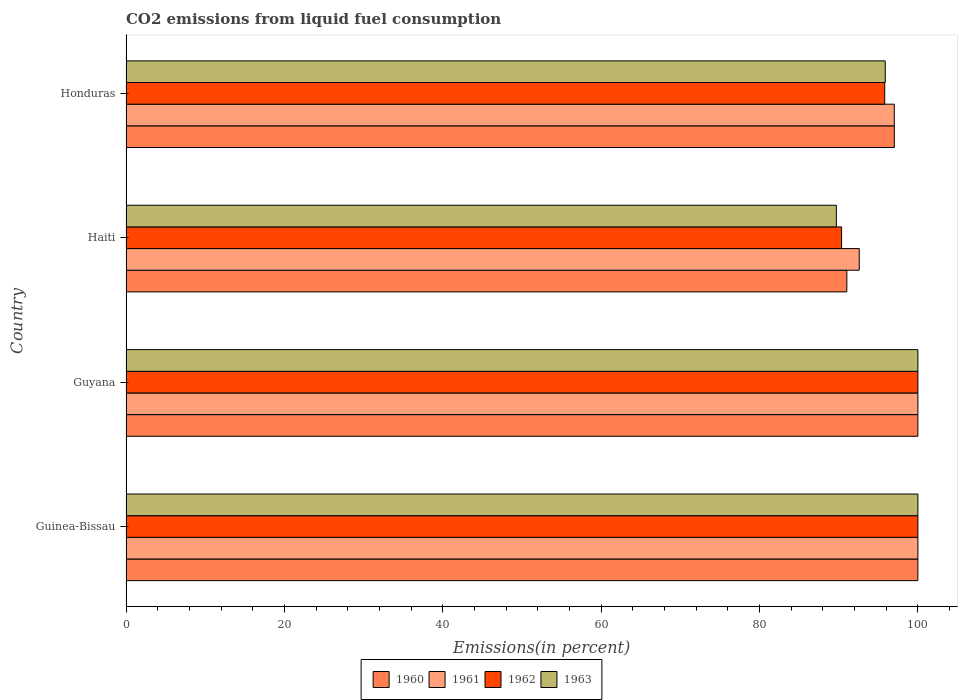How many groups of bars are there?
Provide a succinct answer. 4. Are the number of bars per tick equal to the number of legend labels?
Offer a very short reply. Yes. Are the number of bars on each tick of the Y-axis equal?
Provide a short and direct response. Yes. What is the label of the 3rd group of bars from the top?
Offer a terse response. Guyana. In how many cases, is the number of bars for a given country not equal to the number of legend labels?
Your answer should be compact. 0. Across all countries, what is the maximum total CO2 emitted in 1963?
Your answer should be very brief. 100. Across all countries, what is the minimum total CO2 emitted in 1960?
Your response must be concise. 91.03. In which country was the total CO2 emitted in 1960 maximum?
Provide a short and direct response. Guinea-Bissau. In which country was the total CO2 emitted in 1960 minimum?
Ensure brevity in your answer.  Haiti. What is the total total CO2 emitted in 1963 in the graph?
Make the answer very short. 385.58. What is the difference between the total CO2 emitted in 1963 in Haiti and the total CO2 emitted in 1961 in Honduras?
Offer a very short reply. -7.31. What is the average total CO2 emitted in 1963 per country?
Offer a very short reply. 96.4. In how many countries, is the total CO2 emitted in 1960 greater than 24 %?
Offer a very short reply. 4. What is the ratio of the total CO2 emitted in 1960 in Haiti to that in Honduras?
Provide a short and direct response. 0.94. Is the total CO2 emitted in 1963 in Guinea-Bissau less than that in Haiti?
Give a very brief answer. No. Is the difference between the total CO2 emitted in 1963 in Guinea-Bissau and Guyana greater than the difference between the total CO2 emitted in 1960 in Guinea-Bissau and Guyana?
Provide a succinct answer. No. What is the difference between the highest and the second highest total CO2 emitted in 1962?
Ensure brevity in your answer.  0. What is the difference between the highest and the lowest total CO2 emitted in 1963?
Provide a succinct answer. 10.29. In how many countries, is the total CO2 emitted in 1961 greater than the average total CO2 emitted in 1961 taken over all countries?
Make the answer very short. 2. What does the 4th bar from the top in Haiti represents?
Give a very brief answer. 1960. What does the 4th bar from the bottom in Guyana represents?
Your answer should be very brief. 1963. How many bars are there?
Your response must be concise. 16. Are all the bars in the graph horizontal?
Keep it short and to the point. Yes. How many countries are there in the graph?
Provide a short and direct response. 4. What is the difference between two consecutive major ticks on the X-axis?
Keep it short and to the point. 20. Does the graph contain any zero values?
Keep it short and to the point. No. How many legend labels are there?
Keep it short and to the point. 4. How are the legend labels stacked?
Offer a terse response. Horizontal. What is the title of the graph?
Your response must be concise. CO2 emissions from liquid fuel consumption. What is the label or title of the X-axis?
Offer a very short reply. Emissions(in percent). What is the label or title of the Y-axis?
Your answer should be compact. Country. What is the Emissions(in percent) of 1960 in Guinea-Bissau?
Give a very brief answer. 100. What is the Emissions(in percent) of 1961 in Guinea-Bissau?
Your response must be concise. 100. What is the Emissions(in percent) of 1963 in Guinea-Bissau?
Keep it short and to the point. 100. What is the Emissions(in percent) in 1960 in Guyana?
Offer a very short reply. 100. What is the Emissions(in percent) of 1960 in Haiti?
Ensure brevity in your answer.  91.03. What is the Emissions(in percent) in 1961 in Haiti?
Provide a short and direct response. 92.59. What is the Emissions(in percent) of 1962 in Haiti?
Make the answer very short. 90.36. What is the Emissions(in percent) in 1963 in Haiti?
Offer a terse response. 89.71. What is the Emissions(in percent) of 1960 in Honduras?
Provide a succinct answer. 97.02. What is the Emissions(in percent) in 1961 in Honduras?
Your answer should be very brief. 97.01. What is the Emissions(in percent) in 1962 in Honduras?
Make the answer very short. 95.81. What is the Emissions(in percent) of 1963 in Honduras?
Make the answer very short. 95.88. Across all countries, what is the maximum Emissions(in percent) of 1960?
Give a very brief answer. 100. Across all countries, what is the maximum Emissions(in percent) in 1962?
Keep it short and to the point. 100. Across all countries, what is the maximum Emissions(in percent) in 1963?
Provide a succinct answer. 100. Across all countries, what is the minimum Emissions(in percent) in 1960?
Make the answer very short. 91.03. Across all countries, what is the minimum Emissions(in percent) of 1961?
Provide a succinct answer. 92.59. Across all countries, what is the minimum Emissions(in percent) of 1962?
Your answer should be compact. 90.36. Across all countries, what is the minimum Emissions(in percent) of 1963?
Your answer should be compact. 89.71. What is the total Emissions(in percent) of 1960 in the graph?
Your answer should be very brief. 388.05. What is the total Emissions(in percent) of 1961 in the graph?
Your answer should be very brief. 389.61. What is the total Emissions(in percent) of 1962 in the graph?
Give a very brief answer. 386.17. What is the total Emissions(in percent) of 1963 in the graph?
Offer a terse response. 385.58. What is the difference between the Emissions(in percent) in 1962 in Guinea-Bissau and that in Guyana?
Provide a short and direct response. 0. What is the difference between the Emissions(in percent) of 1960 in Guinea-Bissau and that in Haiti?
Make the answer very short. 8.97. What is the difference between the Emissions(in percent) of 1961 in Guinea-Bissau and that in Haiti?
Offer a very short reply. 7.41. What is the difference between the Emissions(in percent) of 1962 in Guinea-Bissau and that in Haiti?
Make the answer very short. 9.64. What is the difference between the Emissions(in percent) of 1963 in Guinea-Bissau and that in Haiti?
Offer a terse response. 10.29. What is the difference between the Emissions(in percent) of 1960 in Guinea-Bissau and that in Honduras?
Keep it short and to the point. 2.98. What is the difference between the Emissions(in percent) of 1961 in Guinea-Bissau and that in Honduras?
Offer a terse response. 2.99. What is the difference between the Emissions(in percent) in 1962 in Guinea-Bissau and that in Honduras?
Keep it short and to the point. 4.19. What is the difference between the Emissions(in percent) in 1963 in Guinea-Bissau and that in Honduras?
Offer a terse response. 4.12. What is the difference between the Emissions(in percent) in 1960 in Guyana and that in Haiti?
Keep it short and to the point. 8.97. What is the difference between the Emissions(in percent) of 1961 in Guyana and that in Haiti?
Offer a very short reply. 7.41. What is the difference between the Emissions(in percent) of 1962 in Guyana and that in Haiti?
Offer a very short reply. 9.64. What is the difference between the Emissions(in percent) in 1963 in Guyana and that in Haiti?
Your answer should be very brief. 10.29. What is the difference between the Emissions(in percent) in 1960 in Guyana and that in Honduras?
Your response must be concise. 2.98. What is the difference between the Emissions(in percent) of 1961 in Guyana and that in Honduras?
Ensure brevity in your answer.  2.99. What is the difference between the Emissions(in percent) of 1962 in Guyana and that in Honduras?
Keep it short and to the point. 4.19. What is the difference between the Emissions(in percent) of 1963 in Guyana and that in Honduras?
Make the answer very short. 4.12. What is the difference between the Emissions(in percent) in 1960 in Haiti and that in Honduras?
Provide a succinct answer. -6. What is the difference between the Emissions(in percent) of 1961 in Haiti and that in Honduras?
Your answer should be very brief. -4.42. What is the difference between the Emissions(in percent) of 1962 in Haiti and that in Honduras?
Your answer should be very brief. -5.45. What is the difference between the Emissions(in percent) of 1963 in Haiti and that in Honduras?
Offer a very short reply. -6.17. What is the difference between the Emissions(in percent) of 1960 in Guinea-Bissau and the Emissions(in percent) of 1963 in Guyana?
Your response must be concise. 0. What is the difference between the Emissions(in percent) of 1962 in Guinea-Bissau and the Emissions(in percent) of 1963 in Guyana?
Your response must be concise. 0. What is the difference between the Emissions(in percent) of 1960 in Guinea-Bissau and the Emissions(in percent) of 1961 in Haiti?
Make the answer very short. 7.41. What is the difference between the Emissions(in percent) of 1960 in Guinea-Bissau and the Emissions(in percent) of 1962 in Haiti?
Provide a succinct answer. 9.64. What is the difference between the Emissions(in percent) of 1960 in Guinea-Bissau and the Emissions(in percent) of 1963 in Haiti?
Make the answer very short. 10.29. What is the difference between the Emissions(in percent) of 1961 in Guinea-Bissau and the Emissions(in percent) of 1962 in Haiti?
Ensure brevity in your answer.  9.64. What is the difference between the Emissions(in percent) of 1961 in Guinea-Bissau and the Emissions(in percent) of 1963 in Haiti?
Keep it short and to the point. 10.29. What is the difference between the Emissions(in percent) of 1962 in Guinea-Bissau and the Emissions(in percent) of 1963 in Haiti?
Ensure brevity in your answer.  10.29. What is the difference between the Emissions(in percent) of 1960 in Guinea-Bissau and the Emissions(in percent) of 1961 in Honduras?
Your response must be concise. 2.99. What is the difference between the Emissions(in percent) in 1960 in Guinea-Bissau and the Emissions(in percent) in 1962 in Honduras?
Offer a terse response. 4.19. What is the difference between the Emissions(in percent) of 1960 in Guinea-Bissau and the Emissions(in percent) of 1963 in Honduras?
Offer a very short reply. 4.12. What is the difference between the Emissions(in percent) in 1961 in Guinea-Bissau and the Emissions(in percent) in 1962 in Honduras?
Keep it short and to the point. 4.19. What is the difference between the Emissions(in percent) of 1961 in Guinea-Bissau and the Emissions(in percent) of 1963 in Honduras?
Your response must be concise. 4.12. What is the difference between the Emissions(in percent) in 1962 in Guinea-Bissau and the Emissions(in percent) in 1963 in Honduras?
Keep it short and to the point. 4.12. What is the difference between the Emissions(in percent) in 1960 in Guyana and the Emissions(in percent) in 1961 in Haiti?
Provide a short and direct response. 7.41. What is the difference between the Emissions(in percent) of 1960 in Guyana and the Emissions(in percent) of 1962 in Haiti?
Offer a terse response. 9.64. What is the difference between the Emissions(in percent) of 1960 in Guyana and the Emissions(in percent) of 1963 in Haiti?
Ensure brevity in your answer.  10.29. What is the difference between the Emissions(in percent) in 1961 in Guyana and the Emissions(in percent) in 1962 in Haiti?
Offer a terse response. 9.64. What is the difference between the Emissions(in percent) of 1961 in Guyana and the Emissions(in percent) of 1963 in Haiti?
Your answer should be compact. 10.29. What is the difference between the Emissions(in percent) of 1962 in Guyana and the Emissions(in percent) of 1963 in Haiti?
Your answer should be very brief. 10.29. What is the difference between the Emissions(in percent) of 1960 in Guyana and the Emissions(in percent) of 1961 in Honduras?
Your answer should be very brief. 2.99. What is the difference between the Emissions(in percent) in 1960 in Guyana and the Emissions(in percent) in 1962 in Honduras?
Provide a short and direct response. 4.19. What is the difference between the Emissions(in percent) of 1960 in Guyana and the Emissions(in percent) of 1963 in Honduras?
Give a very brief answer. 4.12. What is the difference between the Emissions(in percent) in 1961 in Guyana and the Emissions(in percent) in 1962 in Honduras?
Keep it short and to the point. 4.19. What is the difference between the Emissions(in percent) in 1961 in Guyana and the Emissions(in percent) in 1963 in Honduras?
Offer a terse response. 4.12. What is the difference between the Emissions(in percent) of 1962 in Guyana and the Emissions(in percent) of 1963 in Honduras?
Make the answer very short. 4.12. What is the difference between the Emissions(in percent) in 1960 in Haiti and the Emissions(in percent) in 1961 in Honduras?
Make the answer very short. -5.99. What is the difference between the Emissions(in percent) in 1960 in Haiti and the Emissions(in percent) in 1962 in Honduras?
Offer a terse response. -4.79. What is the difference between the Emissions(in percent) of 1960 in Haiti and the Emissions(in percent) of 1963 in Honduras?
Provide a short and direct response. -4.85. What is the difference between the Emissions(in percent) of 1961 in Haiti and the Emissions(in percent) of 1962 in Honduras?
Your answer should be compact. -3.22. What is the difference between the Emissions(in percent) of 1961 in Haiti and the Emissions(in percent) of 1963 in Honduras?
Provide a short and direct response. -3.28. What is the difference between the Emissions(in percent) of 1962 in Haiti and the Emissions(in percent) of 1963 in Honduras?
Give a very brief answer. -5.51. What is the average Emissions(in percent) in 1960 per country?
Give a very brief answer. 97.01. What is the average Emissions(in percent) in 1961 per country?
Your answer should be very brief. 97.4. What is the average Emissions(in percent) of 1962 per country?
Provide a short and direct response. 96.54. What is the average Emissions(in percent) of 1963 per country?
Keep it short and to the point. 96.4. What is the difference between the Emissions(in percent) of 1960 and Emissions(in percent) of 1961 in Guinea-Bissau?
Keep it short and to the point. 0. What is the difference between the Emissions(in percent) of 1960 and Emissions(in percent) of 1962 in Guinea-Bissau?
Keep it short and to the point. 0. What is the difference between the Emissions(in percent) in 1960 and Emissions(in percent) in 1961 in Guyana?
Keep it short and to the point. 0. What is the difference between the Emissions(in percent) in 1960 and Emissions(in percent) in 1961 in Haiti?
Make the answer very short. -1.57. What is the difference between the Emissions(in percent) of 1960 and Emissions(in percent) of 1962 in Haiti?
Give a very brief answer. 0.66. What is the difference between the Emissions(in percent) of 1960 and Emissions(in percent) of 1963 in Haiti?
Give a very brief answer. 1.32. What is the difference between the Emissions(in percent) in 1961 and Emissions(in percent) in 1962 in Haiti?
Your response must be concise. 2.23. What is the difference between the Emissions(in percent) in 1961 and Emissions(in percent) in 1963 in Haiti?
Provide a short and direct response. 2.89. What is the difference between the Emissions(in percent) of 1962 and Emissions(in percent) of 1963 in Haiti?
Offer a very short reply. 0.66. What is the difference between the Emissions(in percent) of 1960 and Emissions(in percent) of 1961 in Honduras?
Provide a succinct answer. 0.01. What is the difference between the Emissions(in percent) of 1960 and Emissions(in percent) of 1962 in Honduras?
Ensure brevity in your answer.  1.21. What is the difference between the Emissions(in percent) of 1960 and Emissions(in percent) of 1963 in Honduras?
Make the answer very short. 1.15. What is the difference between the Emissions(in percent) in 1961 and Emissions(in percent) in 1962 in Honduras?
Ensure brevity in your answer.  1.2. What is the difference between the Emissions(in percent) of 1961 and Emissions(in percent) of 1963 in Honduras?
Offer a very short reply. 1.14. What is the difference between the Emissions(in percent) in 1962 and Emissions(in percent) in 1963 in Honduras?
Give a very brief answer. -0.06. What is the ratio of the Emissions(in percent) in 1960 in Guinea-Bissau to that in Guyana?
Your response must be concise. 1. What is the ratio of the Emissions(in percent) of 1961 in Guinea-Bissau to that in Guyana?
Give a very brief answer. 1. What is the ratio of the Emissions(in percent) of 1963 in Guinea-Bissau to that in Guyana?
Ensure brevity in your answer.  1. What is the ratio of the Emissions(in percent) in 1960 in Guinea-Bissau to that in Haiti?
Offer a terse response. 1.1. What is the ratio of the Emissions(in percent) of 1961 in Guinea-Bissau to that in Haiti?
Ensure brevity in your answer.  1.08. What is the ratio of the Emissions(in percent) of 1962 in Guinea-Bissau to that in Haiti?
Provide a succinct answer. 1.11. What is the ratio of the Emissions(in percent) in 1963 in Guinea-Bissau to that in Haiti?
Your answer should be very brief. 1.11. What is the ratio of the Emissions(in percent) in 1960 in Guinea-Bissau to that in Honduras?
Provide a succinct answer. 1.03. What is the ratio of the Emissions(in percent) in 1961 in Guinea-Bissau to that in Honduras?
Provide a succinct answer. 1.03. What is the ratio of the Emissions(in percent) of 1962 in Guinea-Bissau to that in Honduras?
Offer a terse response. 1.04. What is the ratio of the Emissions(in percent) of 1963 in Guinea-Bissau to that in Honduras?
Offer a very short reply. 1.04. What is the ratio of the Emissions(in percent) of 1960 in Guyana to that in Haiti?
Provide a short and direct response. 1.1. What is the ratio of the Emissions(in percent) of 1962 in Guyana to that in Haiti?
Your answer should be compact. 1.11. What is the ratio of the Emissions(in percent) in 1963 in Guyana to that in Haiti?
Provide a short and direct response. 1.11. What is the ratio of the Emissions(in percent) in 1960 in Guyana to that in Honduras?
Offer a very short reply. 1.03. What is the ratio of the Emissions(in percent) in 1961 in Guyana to that in Honduras?
Give a very brief answer. 1.03. What is the ratio of the Emissions(in percent) in 1962 in Guyana to that in Honduras?
Provide a succinct answer. 1.04. What is the ratio of the Emissions(in percent) of 1963 in Guyana to that in Honduras?
Provide a succinct answer. 1.04. What is the ratio of the Emissions(in percent) of 1960 in Haiti to that in Honduras?
Your answer should be compact. 0.94. What is the ratio of the Emissions(in percent) of 1961 in Haiti to that in Honduras?
Ensure brevity in your answer.  0.95. What is the ratio of the Emissions(in percent) in 1962 in Haiti to that in Honduras?
Your response must be concise. 0.94. What is the ratio of the Emissions(in percent) of 1963 in Haiti to that in Honduras?
Keep it short and to the point. 0.94. What is the difference between the highest and the second highest Emissions(in percent) of 1963?
Your answer should be compact. 0. What is the difference between the highest and the lowest Emissions(in percent) in 1960?
Give a very brief answer. 8.97. What is the difference between the highest and the lowest Emissions(in percent) of 1961?
Give a very brief answer. 7.41. What is the difference between the highest and the lowest Emissions(in percent) of 1962?
Ensure brevity in your answer.  9.64. What is the difference between the highest and the lowest Emissions(in percent) of 1963?
Make the answer very short. 10.29. 